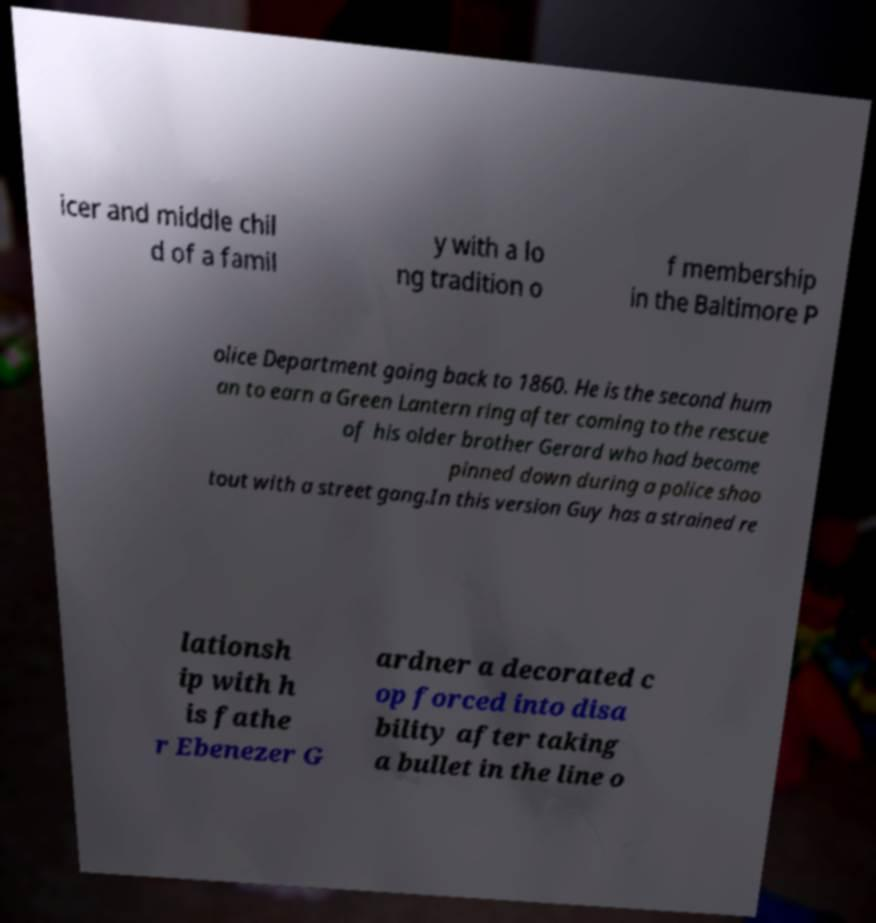Please read and relay the text visible in this image. What does it say? icer and middle chil d of a famil y with a lo ng tradition o f membership in the Baltimore P olice Department going back to 1860. He is the second hum an to earn a Green Lantern ring after coming to the rescue of his older brother Gerard who had become pinned down during a police shoo tout with a street gang.In this version Guy has a strained re lationsh ip with h is fathe r Ebenezer G ardner a decorated c op forced into disa bility after taking a bullet in the line o 